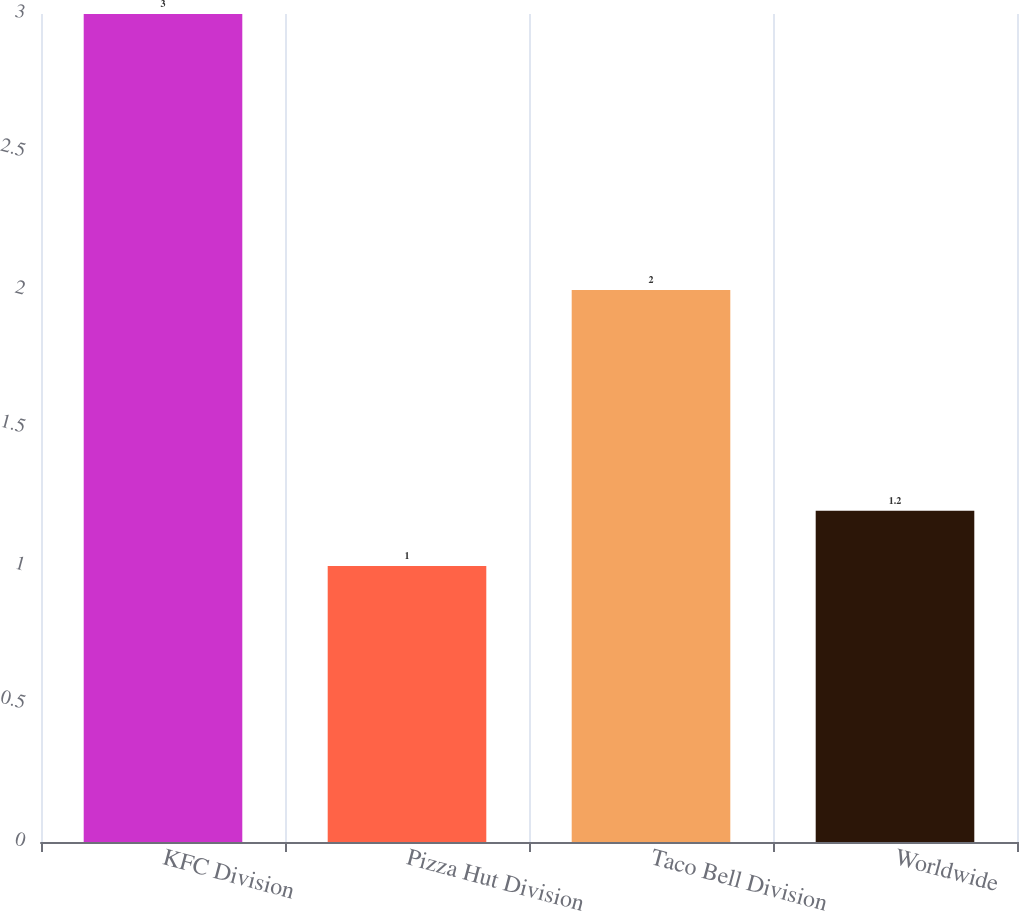Convert chart to OTSL. <chart><loc_0><loc_0><loc_500><loc_500><bar_chart><fcel>KFC Division<fcel>Pizza Hut Division<fcel>Taco Bell Division<fcel>Worldwide<nl><fcel>3<fcel>1<fcel>2<fcel>1.2<nl></chart> 